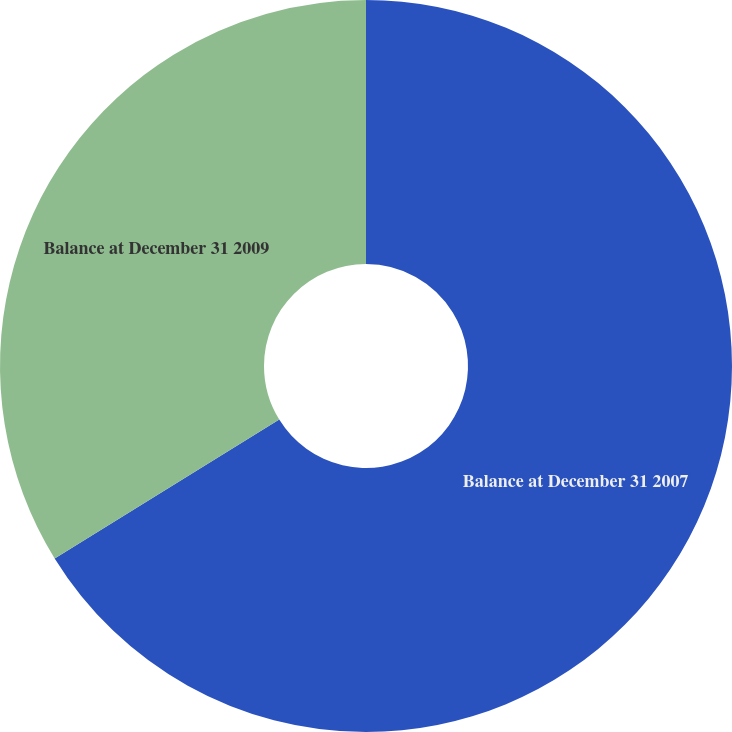<chart> <loc_0><loc_0><loc_500><loc_500><pie_chart><fcel>Balance at December 31 2007<fcel>Balance at December 31 2009<nl><fcel>66.19%<fcel>33.81%<nl></chart> 